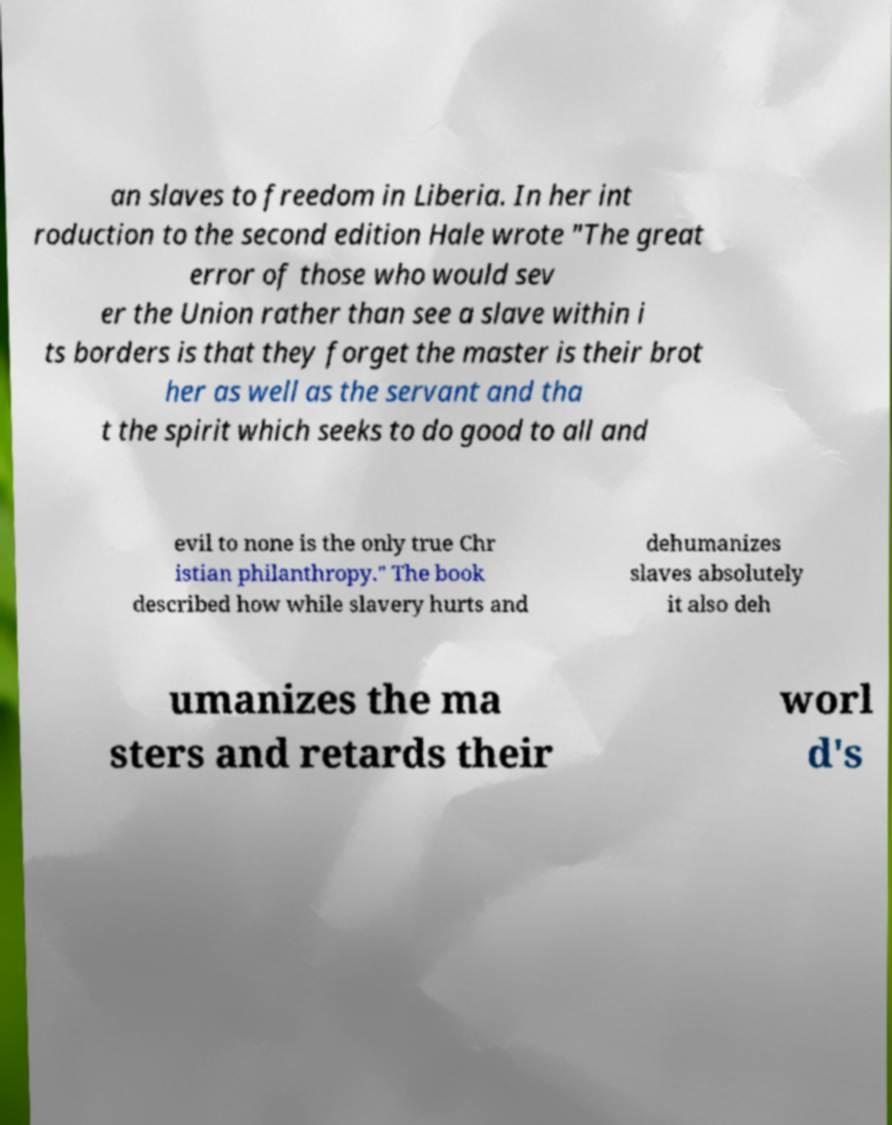I need the written content from this picture converted into text. Can you do that? an slaves to freedom in Liberia. In her int roduction to the second edition Hale wrote "The great error of those who would sev er the Union rather than see a slave within i ts borders is that they forget the master is their brot her as well as the servant and tha t the spirit which seeks to do good to all and evil to none is the only true Chr istian philanthropy." The book described how while slavery hurts and dehumanizes slaves absolutely it also deh umanizes the ma sters and retards their worl d's 